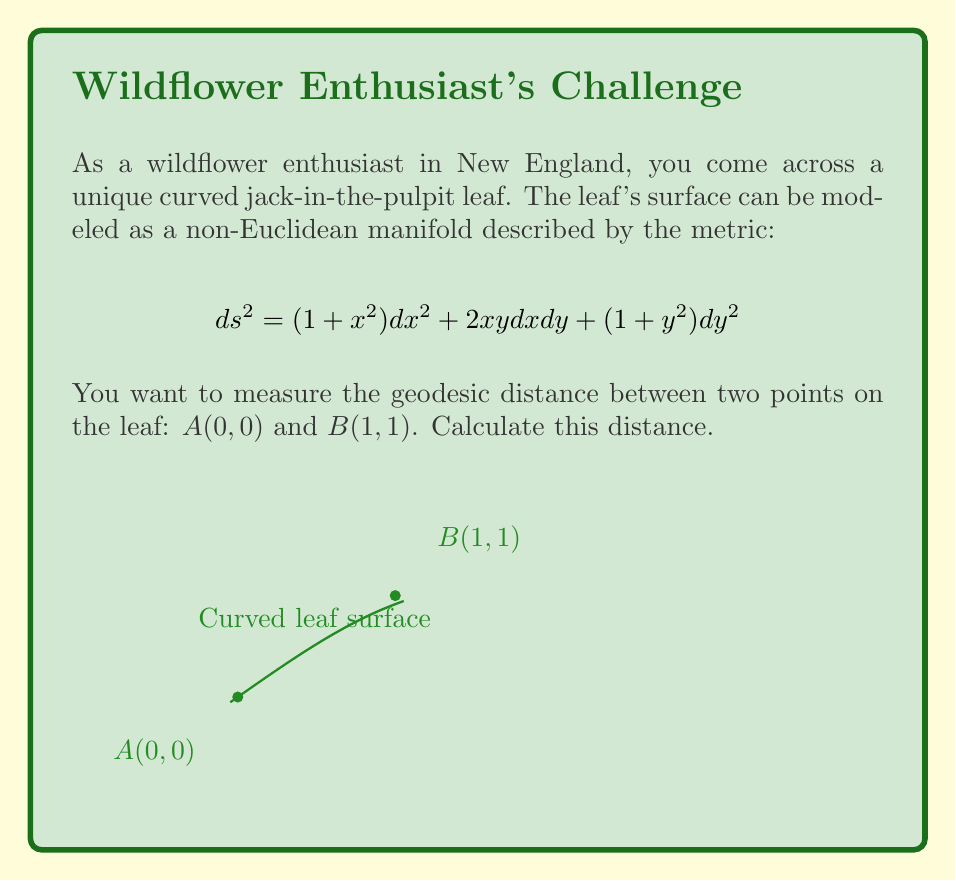Can you solve this math problem? To compute the geodesic distance between two points on a non-Euclidean surface, we need to solve the geodesic equations and then calculate the length of the resulting curve. Here's a step-by-step approach:

1) The metric is given by:
   $$ds^2 = (1 + x^2) dx^2 + 2xy dx dy + (1 + y^2) dy^2$$

2) To find the geodesic, we need to solve the geodesic equations. However, this is a complex differential equation system that doesn't have a simple analytical solution for this metric.

3) Instead, we can use a numerical approximation. One approach is to use the straight line between the points as an initial guess and then iteratively improve it.

4) The straight line between $(0,0)$ and $(1,1)$ can be parameterized as:
   $$x(t) = t, y(t) = t, \quad 0 \leq t \leq 1$$

5) To calculate the length of this curve, we integrate:
   $$L = \int_0^1 \sqrt{(1+t^2) \cdot 1^2 + 2t^2 \cdot 1 \cdot 1 + (1+t^2) \cdot 1^2} dt$$
   $$= \int_0^1 \sqrt{2 + 4t^2} dt$$

6) This integral can be solved analytically:
   $$L = \frac{1}{2} \left[t\sqrt{2+4t^2} + \frac{1}{\sqrt{2}} \ln(2t + \sqrt{2+4t^2})\right]_0^1$$

7) Evaluating the integral:
   $$L = \frac{1}{2} \left[\sqrt{6} + \frac{1}{\sqrt{2}} \ln(2 + \sqrt{6})\right] - 0$$

8) This gives us an upper bound for the geodesic distance. The true geodesic would be slightly shorter than this.

9) To get a more accurate result, we'd need to use numerical methods to solve the geodesic equations and then numerically integrate along that curve.
Answer: $\frac{1}{2} [\sqrt{6} + \frac{1}{\sqrt{2}} \ln(2 + \sqrt{6})]$ (upper bound) 